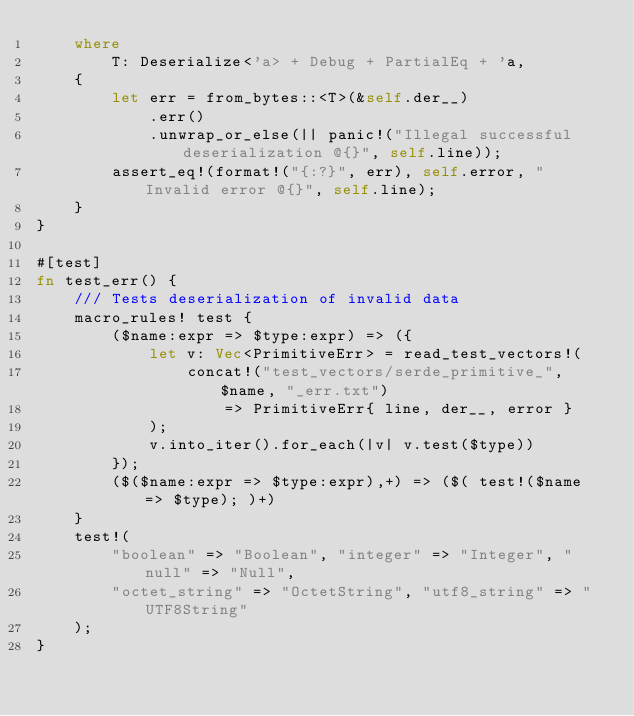<code> <loc_0><loc_0><loc_500><loc_500><_Rust_>    where
        T: Deserialize<'a> + Debug + PartialEq + 'a,
    {
        let err = from_bytes::<T>(&self.der__)
            .err()
            .unwrap_or_else(|| panic!("Illegal successful deserialization @{}", self.line));
        assert_eq!(format!("{:?}", err), self.error, "Invalid error @{}", self.line);
    }
}

#[test]
fn test_err() {
    /// Tests deserialization of invalid data
    macro_rules! test {
		($name:expr => $type:expr) => ({
			let v: Vec<PrimitiveErr> = read_test_vectors!(
				concat!("test_vectors/serde_primitive_", $name, "_err.txt")
					=> PrimitiveErr{ line, der__, error }
			);
			v.into_iter().for_each(|v| v.test($type))
		});
		($($name:expr => $type:expr),+) => ($( test!($name => $type); )+)
	}
    test!(
        "boolean" => "Boolean", "integer" => "Integer", "null" => "Null",
        "octet_string" => "OctetString", "utf8_string" => "UTF8String"
    );
}
</code> 